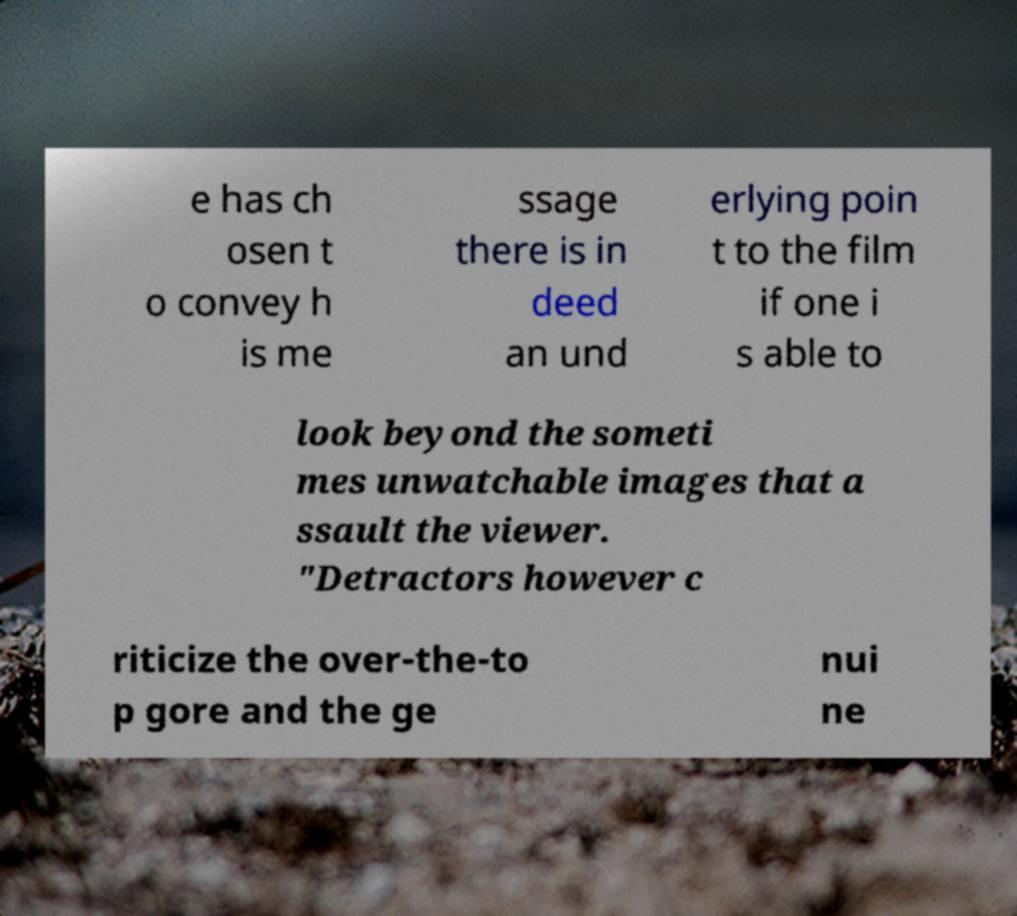There's text embedded in this image that I need extracted. Can you transcribe it verbatim? e has ch osen t o convey h is me ssage there is in deed an und erlying poin t to the film if one i s able to look beyond the someti mes unwatchable images that a ssault the viewer. "Detractors however c riticize the over-the-to p gore and the ge nui ne 